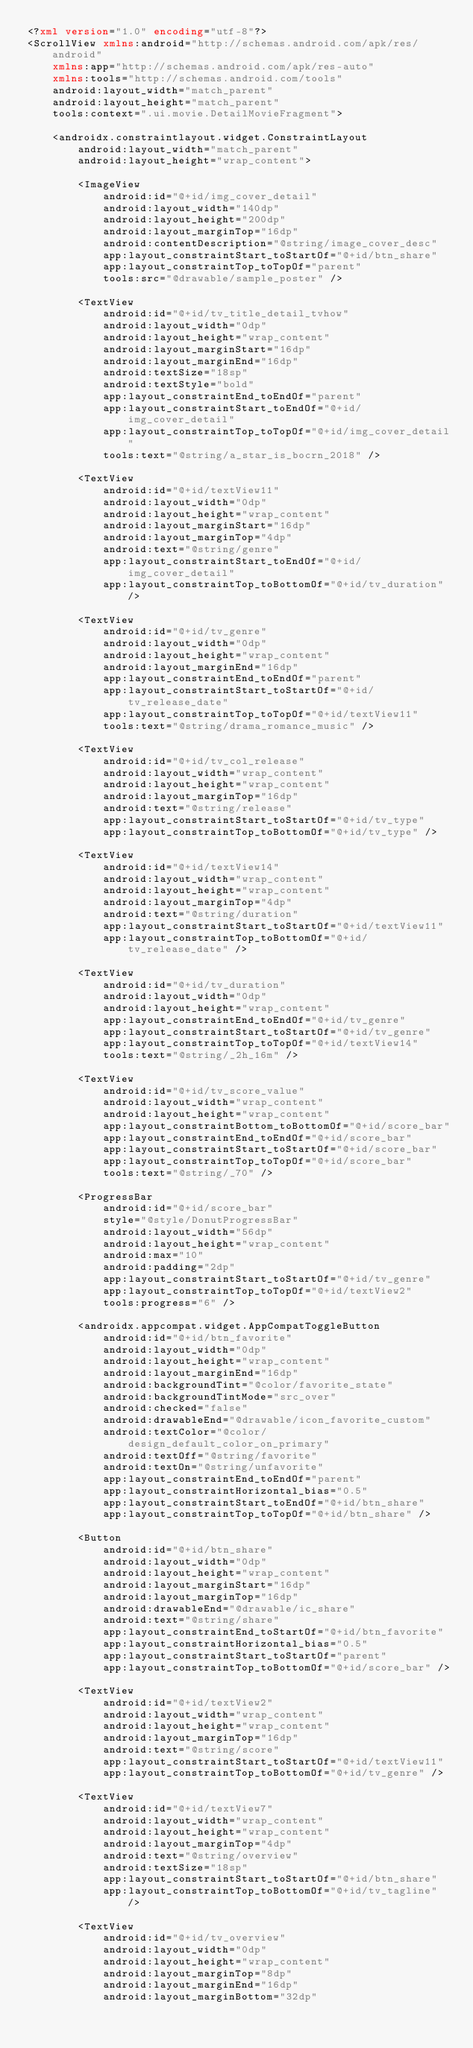<code> <loc_0><loc_0><loc_500><loc_500><_XML_><?xml version="1.0" encoding="utf-8"?>
<ScrollView xmlns:android="http://schemas.android.com/apk/res/android"
    xmlns:app="http://schemas.android.com/apk/res-auto"
    xmlns:tools="http://schemas.android.com/tools"
    android:layout_width="match_parent"
    android:layout_height="match_parent"
    tools:context=".ui.movie.DetailMovieFragment">

    <androidx.constraintlayout.widget.ConstraintLayout
        android:layout_width="match_parent"
        android:layout_height="wrap_content">

        <ImageView
            android:id="@+id/img_cover_detail"
            android:layout_width="140dp"
            android:layout_height="200dp"
            android:layout_marginTop="16dp"
            android:contentDescription="@string/image_cover_desc"
            app:layout_constraintStart_toStartOf="@+id/btn_share"
            app:layout_constraintTop_toTopOf="parent"
            tools:src="@drawable/sample_poster" />

        <TextView
            android:id="@+id/tv_title_detail_tvhow"
            android:layout_width="0dp"
            android:layout_height="wrap_content"
            android:layout_marginStart="16dp"
            android:layout_marginEnd="16dp"
            android:textSize="18sp"
            android:textStyle="bold"
            app:layout_constraintEnd_toEndOf="parent"
            app:layout_constraintStart_toEndOf="@+id/img_cover_detail"
            app:layout_constraintTop_toTopOf="@+id/img_cover_detail"
            tools:text="@string/a_star_is_bocrn_2018" />

        <TextView
            android:id="@+id/textView11"
            android:layout_width="0dp"
            android:layout_height="wrap_content"
            android:layout_marginStart="16dp"
            android:layout_marginTop="4dp"
            android:text="@string/genre"
            app:layout_constraintStart_toEndOf="@+id/img_cover_detail"
            app:layout_constraintTop_toBottomOf="@+id/tv_duration" />

        <TextView
            android:id="@+id/tv_genre"
            android:layout_width="0dp"
            android:layout_height="wrap_content"
            android:layout_marginEnd="16dp"
            app:layout_constraintEnd_toEndOf="parent"
            app:layout_constraintStart_toStartOf="@+id/tv_release_date"
            app:layout_constraintTop_toTopOf="@+id/textView11"
            tools:text="@string/drama_romance_music" />

        <TextView
            android:id="@+id/tv_col_release"
            android:layout_width="wrap_content"
            android:layout_height="wrap_content"
            android:layout_marginTop="16dp"
            android:text="@string/release"
            app:layout_constraintStart_toStartOf="@+id/tv_type"
            app:layout_constraintTop_toBottomOf="@+id/tv_type" />

        <TextView
            android:id="@+id/textView14"
            android:layout_width="wrap_content"
            android:layout_height="wrap_content"
            android:layout_marginTop="4dp"
            android:text="@string/duration"
            app:layout_constraintStart_toStartOf="@+id/textView11"
            app:layout_constraintTop_toBottomOf="@+id/tv_release_date" />

        <TextView
            android:id="@+id/tv_duration"
            android:layout_width="0dp"
            android:layout_height="wrap_content"
            app:layout_constraintEnd_toEndOf="@+id/tv_genre"
            app:layout_constraintStart_toStartOf="@+id/tv_genre"
            app:layout_constraintTop_toTopOf="@+id/textView14"
            tools:text="@string/_2h_16m" />

        <TextView
            android:id="@+id/tv_score_value"
            android:layout_width="wrap_content"
            android:layout_height="wrap_content"
            app:layout_constraintBottom_toBottomOf="@+id/score_bar"
            app:layout_constraintEnd_toEndOf="@+id/score_bar"
            app:layout_constraintStart_toStartOf="@+id/score_bar"
            app:layout_constraintTop_toTopOf="@+id/score_bar"
            tools:text="@string/_70" />

        <ProgressBar
            android:id="@+id/score_bar"
            style="@style/DonutProgressBar"
            android:layout_width="56dp"
            android:layout_height="wrap_content"
            android:max="10"
            android:padding="2dp"
            app:layout_constraintStart_toStartOf="@+id/tv_genre"
            app:layout_constraintTop_toTopOf="@+id/textView2"
            tools:progress="6" />

        <androidx.appcompat.widget.AppCompatToggleButton
            android:id="@+id/btn_favorite"
            android:layout_width="0dp"
            android:layout_height="wrap_content"
            android:layout_marginEnd="16dp"
            android:backgroundTint="@color/favorite_state"
            android:backgroundTintMode="src_over"
            android:checked="false"
            android:drawableEnd="@drawable/icon_favorite_custom"
            android:textColor="@color/design_default_color_on_primary"
            android:textOff="@string/favorite"
            android:textOn="@string/unfavorite"
            app:layout_constraintEnd_toEndOf="parent"
            app:layout_constraintHorizontal_bias="0.5"
            app:layout_constraintStart_toEndOf="@+id/btn_share"
            app:layout_constraintTop_toTopOf="@+id/btn_share" />

        <Button
            android:id="@+id/btn_share"
            android:layout_width="0dp"
            android:layout_height="wrap_content"
            android:layout_marginStart="16dp"
            android:layout_marginTop="16dp"
            android:drawableEnd="@drawable/ic_share"
            android:text="@string/share"
            app:layout_constraintEnd_toStartOf="@+id/btn_favorite"
            app:layout_constraintHorizontal_bias="0.5"
            app:layout_constraintStart_toStartOf="parent"
            app:layout_constraintTop_toBottomOf="@+id/score_bar" />

        <TextView
            android:id="@+id/textView2"
            android:layout_width="wrap_content"
            android:layout_height="wrap_content"
            android:layout_marginTop="16dp"
            android:text="@string/score"
            app:layout_constraintStart_toStartOf="@+id/textView11"
            app:layout_constraintTop_toBottomOf="@+id/tv_genre" />

        <TextView
            android:id="@+id/textView7"
            android:layout_width="wrap_content"
            android:layout_height="wrap_content"
            android:layout_marginTop="4dp"
            android:text="@string/overview"
            android:textSize="18sp"
            app:layout_constraintStart_toStartOf="@+id/btn_share"
            app:layout_constraintTop_toBottomOf="@+id/tv_tagline" />

        <TextView
            android:id="@+id/tv_overview"
            android:layout_width="0dp"
            android:layout_height="wrap_content"
            android:layout_marginTop="8dp"
            android:layout_marginEnd="16dp"
            android:layout_marginBottom="32dp"</code> 